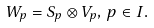Convert formula to latex. <formula><loc_0><loc_0><loc_500><loc_500>W _ { p } = S _ { p } \otimes V _ { p } , \, p \in I .</formula> 